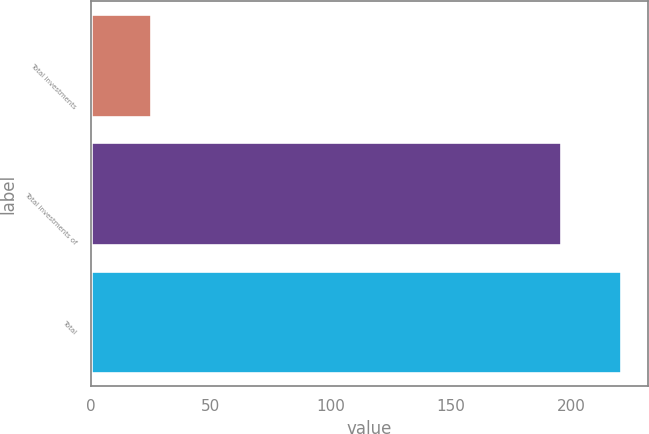Convert chart. <chart><loc_0><loc_0><loc_500><loc_500><bar_chart><fcel>Total investments<fcel>Total investments of<fcel>Total<nl><fcel>25<fcel>196<fcel>221<nl></chart> 